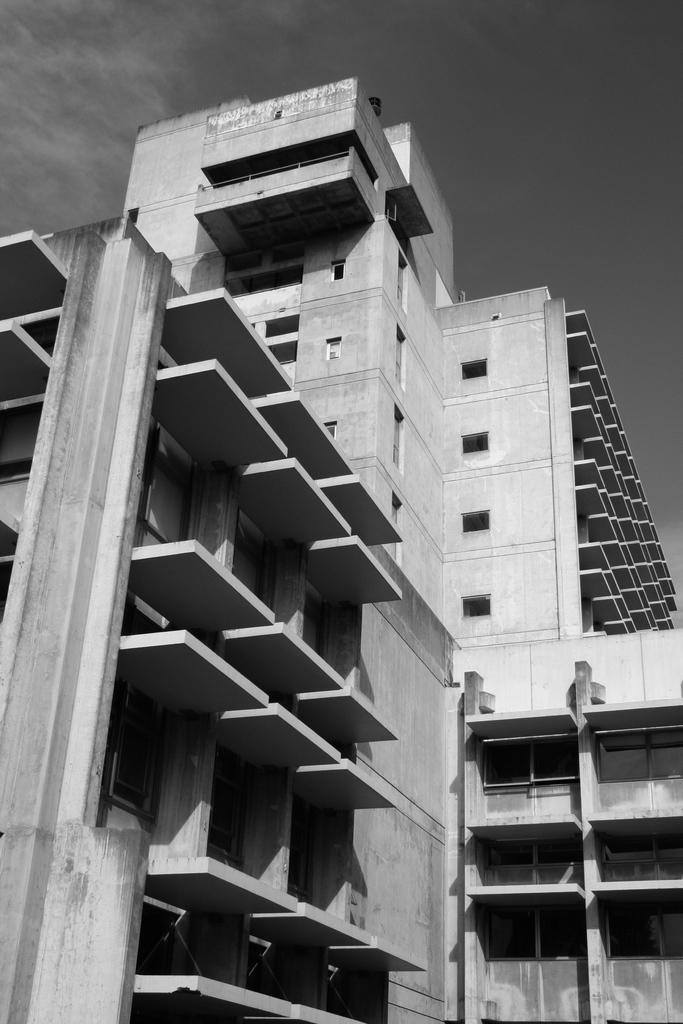Describe this image in one or two sentences. In this image I can see a black and white picture of a building and in the background I can see the sky. 